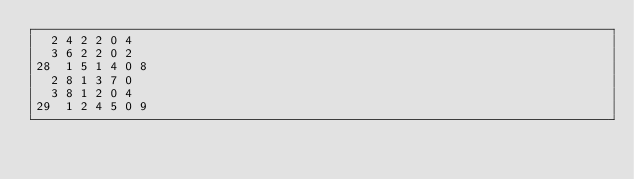Convert code to text. <code><loc_0><loc_0><loc_500><loc_500><_ObjectiveC_>	2	4	2	2	0	4	
	3	6	2	2	0	2	
28	1	5	1	4	0	8	
	2	8	1	3	7	0	
	3	8	1	2	0	4	
29	1	2	4	5	0	9	</code> 